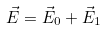Convert formula to latex. <formula><loc_0><loc_0><loc_500><loc_500>\vec { E } = \vec { E } _ { 0 } + \vec { E } _ { 1 }</formula> 